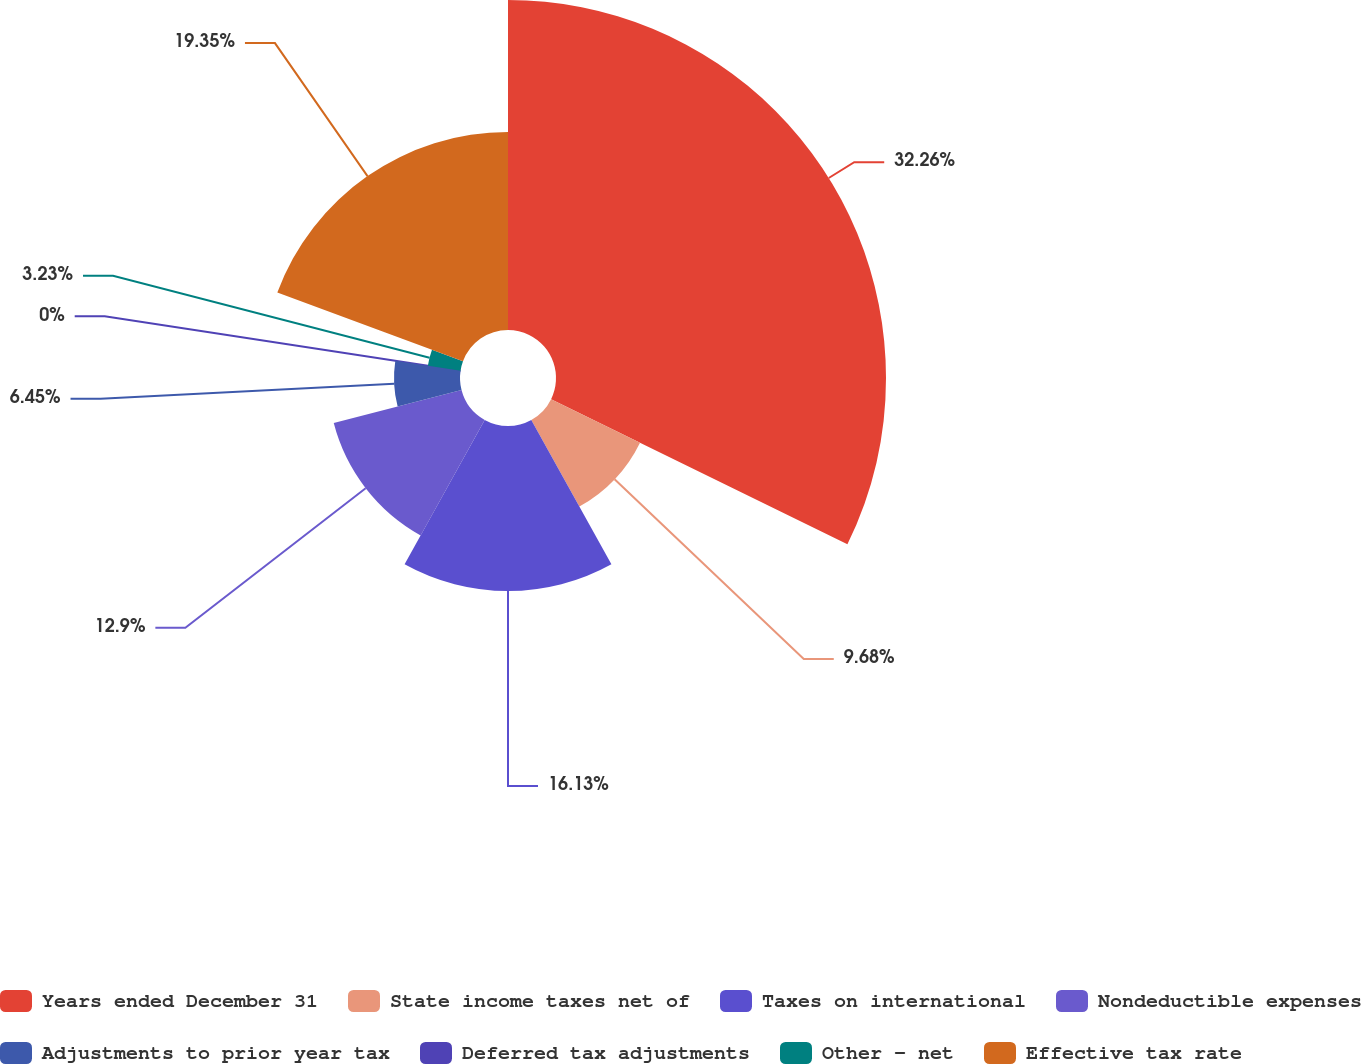<chart> <loc_0><loc_0><loc_500><loc_500><pie_chart><fcel>Years ended December 31<fcel>State income taxes net of<fcel>Taxes on international<fcel>Nondeductible expenses<fcel>Adjustments to prior year tax<fcel>Deferred tax adjustments<fcel>Other - net<fcel>Effective tax rate<nl><fcel>32.25%<fcel>9.68%<fcel>16.13%<fcel>12.9%<fcel>6.45%<fcel>0.0%<fcel>3.23%<fcel>19.35%<nl></chart> 